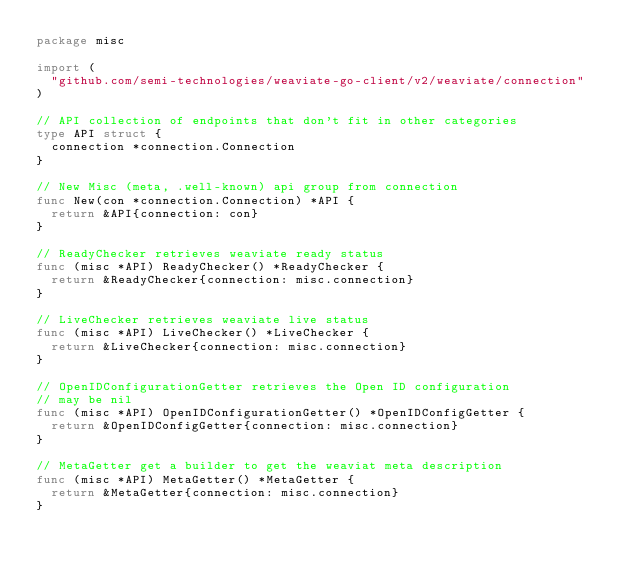Convert code to text. <code><loc_0><loc_0><loc_500><loc_500><_Go_>package misc

import (
	"github.com/semi-technologies/weaviate-go-client/v2/weaviate/connection"
)

// API collection of endpoints that don't fit in other categories
type API struct {
	connection *connection.Connection
}

// New Misc (meta, .well-known) api group from connection
func New(con *connection.Connection) *API {
	return &API{connection: con}
}

// ReadyChecker retrieves weaviate ready status
func (misc *API) ReadyChecker() *ReadyChecker {
	return &ReadyChecker{connection: misc.connection}
}

// LiveChecker retrieves weaviate live status
func (misc *API) LiveChecker() *LiveChecker {
	return &LiveChecker{connection: misc.connection}
}

// OpenIDConfigurationGetter retrieves the Open ID configuration
// may be nil
func (misc *API) OpenIDConfigurationGetter() *OpenIDConfigGetter {
	return &OpenIDConfigGetter{connection: misc.connection}
}

// MetaGetter get a builder to get the weaviat meta description
func (misc *API) MetaGetter() *MetaGetter {
	return &MetaGetter{connection: misc.connection}
}
</code> 